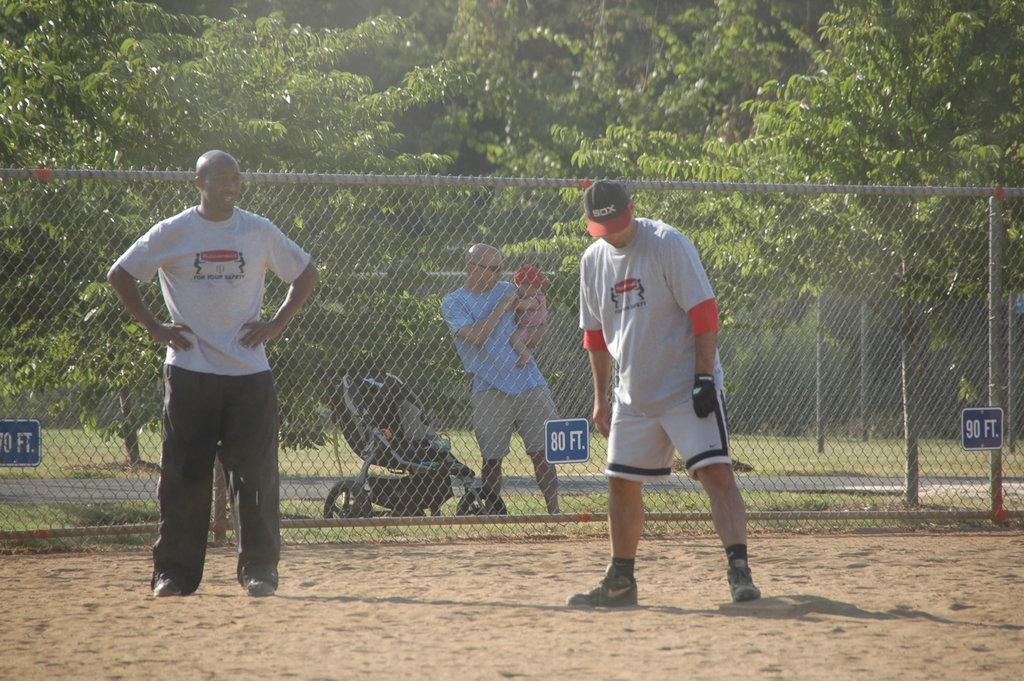Provide a one-sentence caption for the provided image. In front of the man with the baby is a sign giving the distance of 80 ft. 